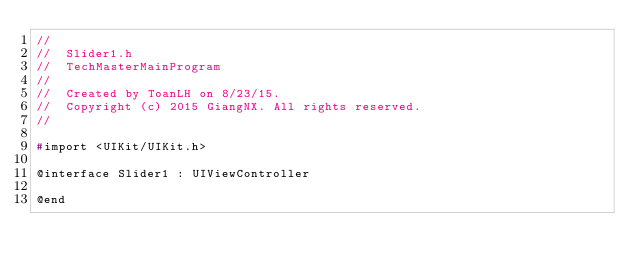Convert code to text. <code><loc_0><loc_0><loc_500><loc_500><_C_>//
//  Slider1.h
//  TechMasterMainProgram
//
//  Created by ToanLH on 8/23/15.
//  Copyright (c) 2015 GiangNX. All rights reserved.
//

#import <UIKit/UIKit.h>

@interface Slider1 : UIViewController

@end
</code> 